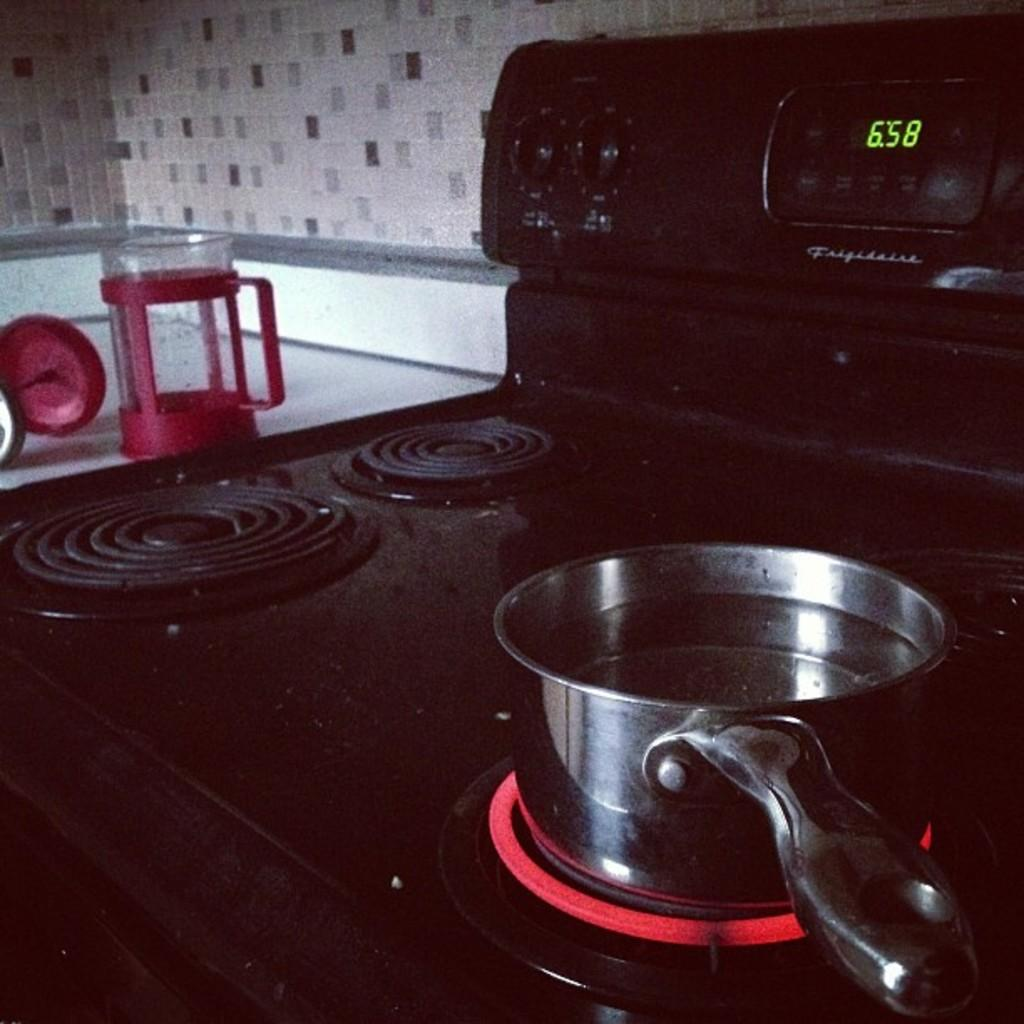<image>
Render a clear and concise summary of the photo. a black stove top shows the time as 6:58 